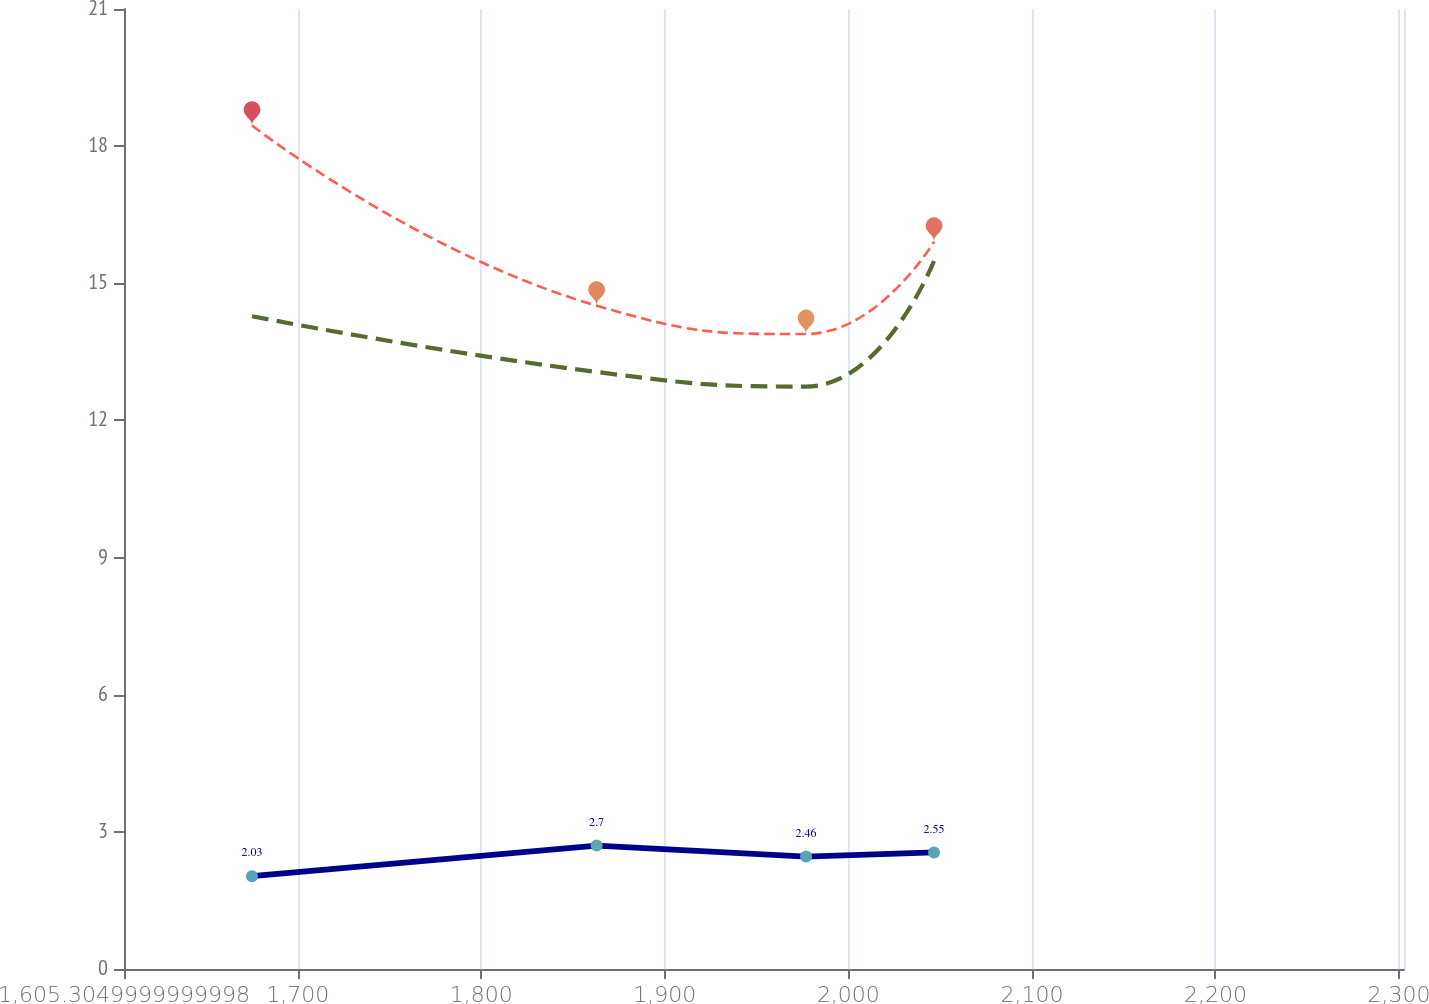<chart> <loc_0><loc_0><loc_500><loc_500><line_chart><ecel><fcel>International<fcel>Domestic<fcel>Total<nl><fcel>1675.05<fcel>14.28<fcel>2.03<fcel>18.45<nl><fcel>1862.83<fcel>13.06<fcel>2.7<fcel>14.51<nl><fcel>1976.94<fcel>12.74<fcel>2.46<fcel>13.89<nl><fcel>2046.68<fcel>15.49<fcel>2.55<fcel>15.91<nl><fcel>2372.5<fcel>12.27<fcel>2.1<fcel>17.85<nl></chart> 